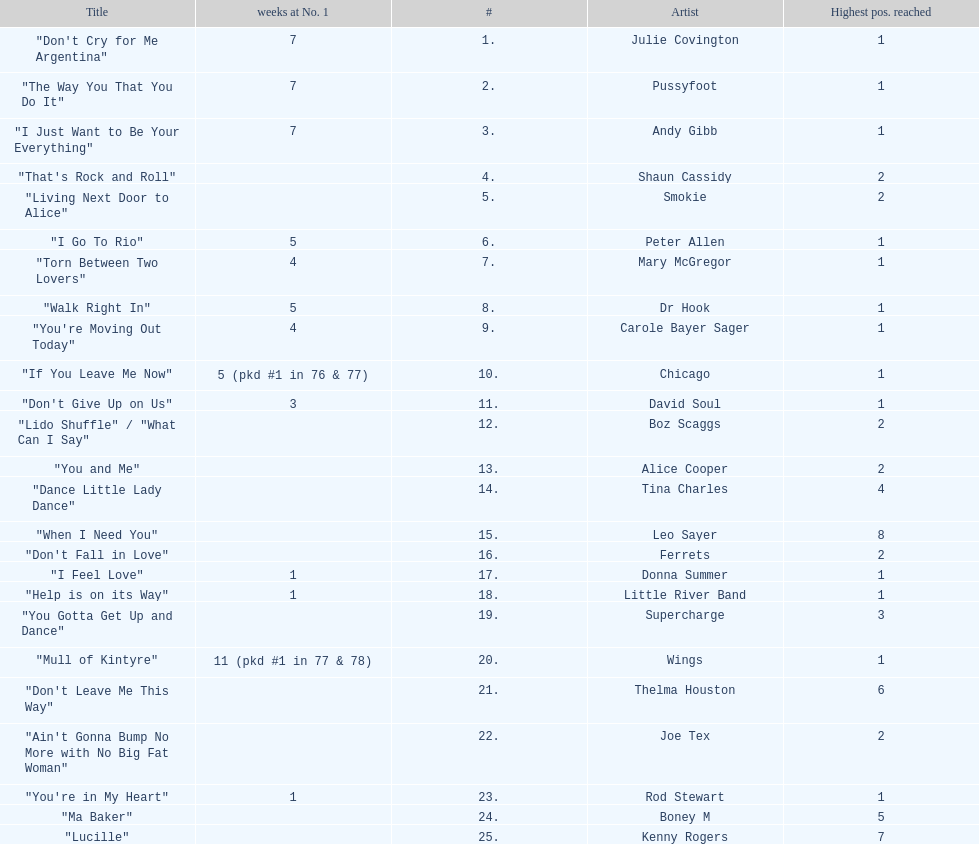Which song stayed at no.1 for the most amount of weeks. "Mull of Kintyre". 